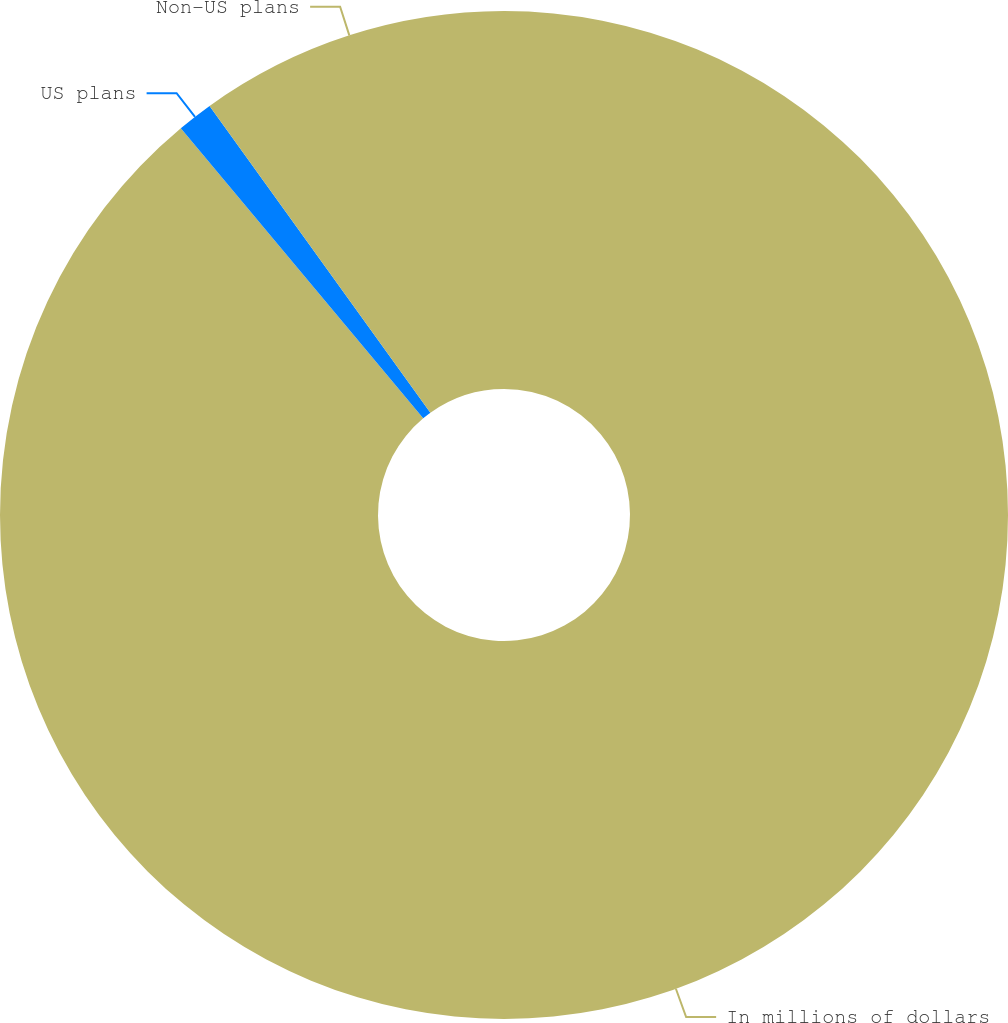Convert chart. <chart><loc_0><loc_0><loc_500><loc_500><pie_chart><fcel>In millions of dollars<fcel>US plans<fcel>Non-US plans<nl><fcel>88.93%<fcel>1.15%<fcel>9.93%<nl></chart> 